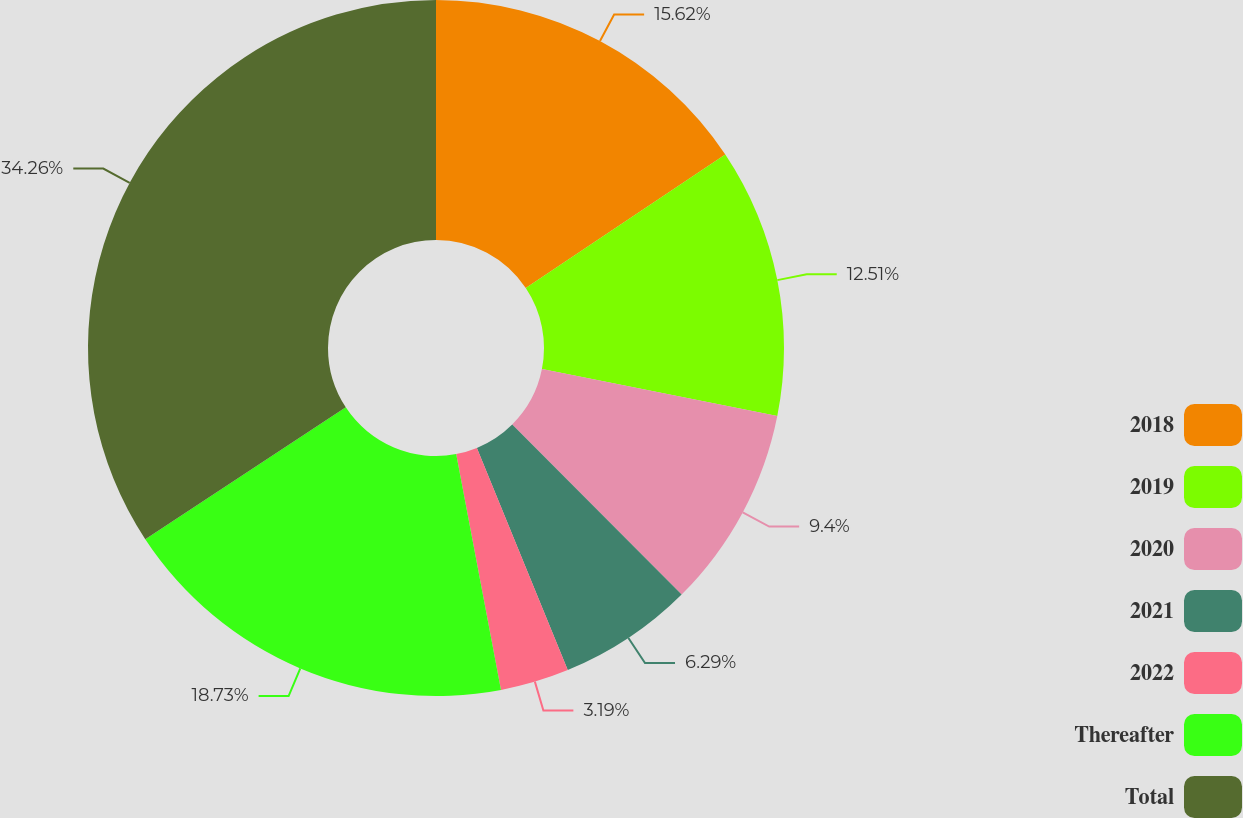Convert chart. <chart><loc_0><loc_0><loc_500><loc_500><pie_chart><fcel>2018<fcel>2019<fcel>2020<fcel>2021<fcel>2022<fcel>Thereafter<fcel>Total<nl><fcel>15.62%<fcel>12.51%<fcel>9.4%<fcel>6.29%<fcel>3.19%<fcel>18.73%<fcel>34.26%<nl></chart> 